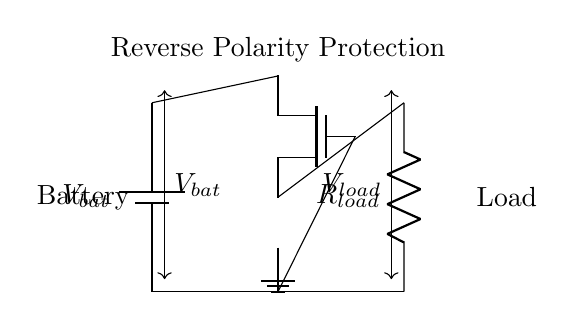What is the main component used for reverse polarity protection? The main component is an NMOS transistor, which acts as a switch to prevent reverse current flow when the battery is connected incorrectly.
Answer: NMOS transistor What does R_load represent in the circuit? R_load represents the load resistor, which is the component that draws current from the battery when the circuit is functioning properly.
Answer: Load resistor What connects the source of the MOSFET to the load? The source of the MOSFET is connected directly to the load, enabling current to flow from the load to ground when the MOSFET is on.
Answer: Source connection What happens if the battery is connected in reverse? If the battery is connected in reverse, the NMOS transistor remains off, preventing current from reaching the load and protecting it from damage.
Answer: No current flow What is the role of the MOSFET gate in this circuit? The MOSFET gate turns the MOSFET on and off based on the voltage applied; in this case, it is tied to the battery's negative terminal to control the current flow.
Answer: Control current flow What is the configuration of the MOSFET in this circuit? The configuration of the NMOS transistor in this circuit is as a low-side switch, allowing it to effectively control the ground connection for the load.
Answer: Low-side switch What is the voltage across R_load when the battery is properly connected? The voltage across R_load is equal to the battery voltage, as all the voltage is dropped across the load when the MOSFET is on.
Answer: Battery voltage 